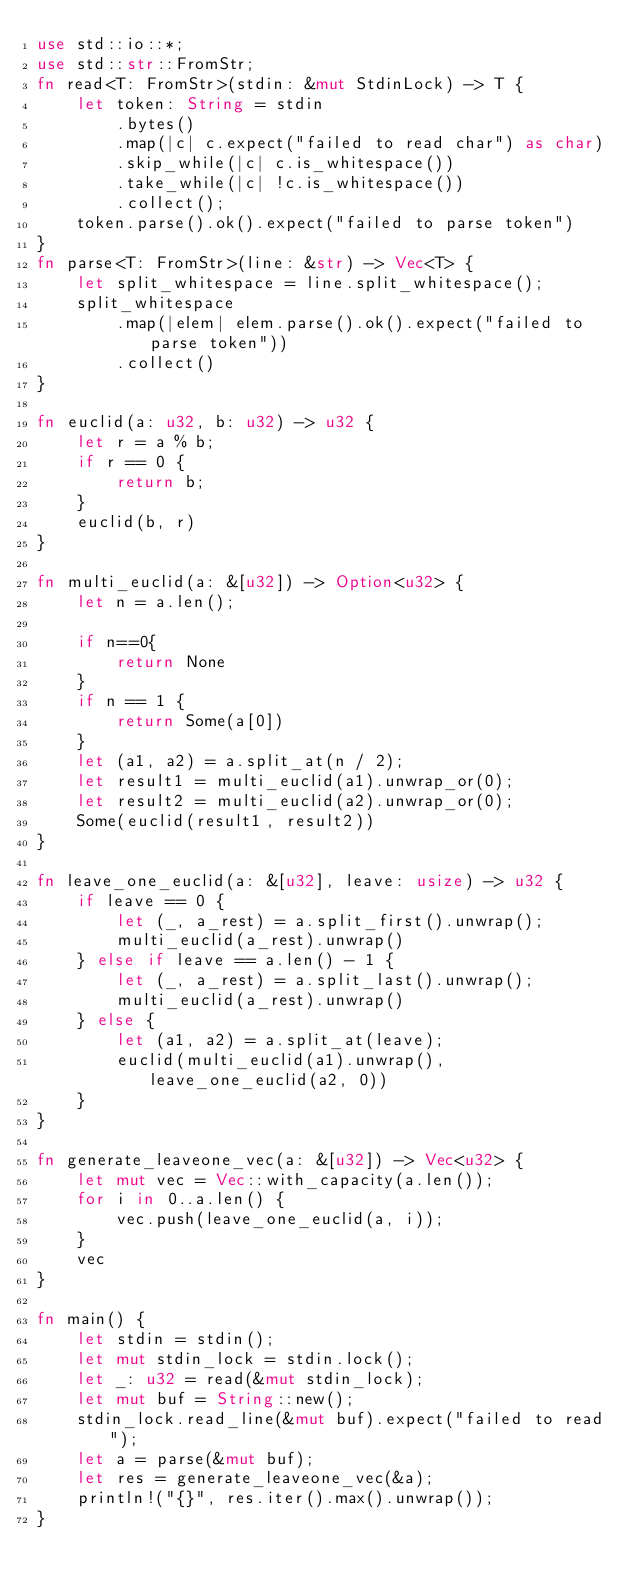Convert code to text. <code><loc_0><loc_0><loc_500><loc_500><_Rust_>use std::io::*;
use std::str::FromStr;
fn read<T: FromStr>(stdin: &mut StdinLock) -> T {
    let token: String = stdin
        .bytes()
        .map(|c| c.expect("failed to read char") as char)
        .skip_while(|c| c.is_whitespace())
        .take_while(|c| !c.is_whitespace())
        .collect();
    token.parse().ok().expect("failed to parse token")
}
fn parse<T: FromStr>(line: &str) -> Vec<T> {
    let split_whitespace = line.split_whitespace();
    split_whitespace
        .map(|elem| elem.parse().ok().expect("failed to parse token"))
        .collect()
}

fn euclid(a: u32, b: u32) -> u32 {
    let r = a % b;
    if r == 0 {
        return b;
    }
    euclid(b, r)
}

fn multi_euclid(a: &[u32]) -> Option<u32> {
    let n = a.len();

    if n==0{
        return None
    }
    if n == 1 {
        return Some(a[0])
    }
    let (a1, a2) = a.split_at(n / 2);
    let result1 = multi_euclid(a1).unwrap_or(0);
    let result2 = multi_euclid(a2).unwrap_or(0);
    Some(euclid(result1, result2))
}

fn leave_one_euclid(a: &[u32], leave: usize) -> u32 {
    if leave == 0 {
        let (_, a_rest) = a.split_first().unwrap();
        multi_euclid(a_rest).unwrap()
    } else if leave == a.len() - 1 {
        let (_, a_rest) = a.split_last().unwrap();
        multi_euclid(a_rest).unwrap()
    } else {
        let (a1, a2) = a.split_at(leave);
        euclid(multi_euclid(a1).unwrap(), leave_one_euclid(a2, 0))
    }
}

fn generate_leaveone_vec(a: &[u32]) -> Vec<u32> {
    let mut vec = Vec::with_capacity(a.len());
    for i in 0..a.len() {
        vec.push(leave_one_euclid(a, i));
    }
    vec
}

fn main() {
    let stdin = stdin();
    let mut stdin_lock = stdin.lock();
    let _: u32 = read(&mut stdin_lock);
    let mut buf = String::new();
    stdin_lock.read_line(&mut buf).expect("failed to read");
    let a = parse(&mut buf);
    let res = generate_leaveone_vec(&a);
    println!("{}", res.iter().max().unwrap());
}
</code> 